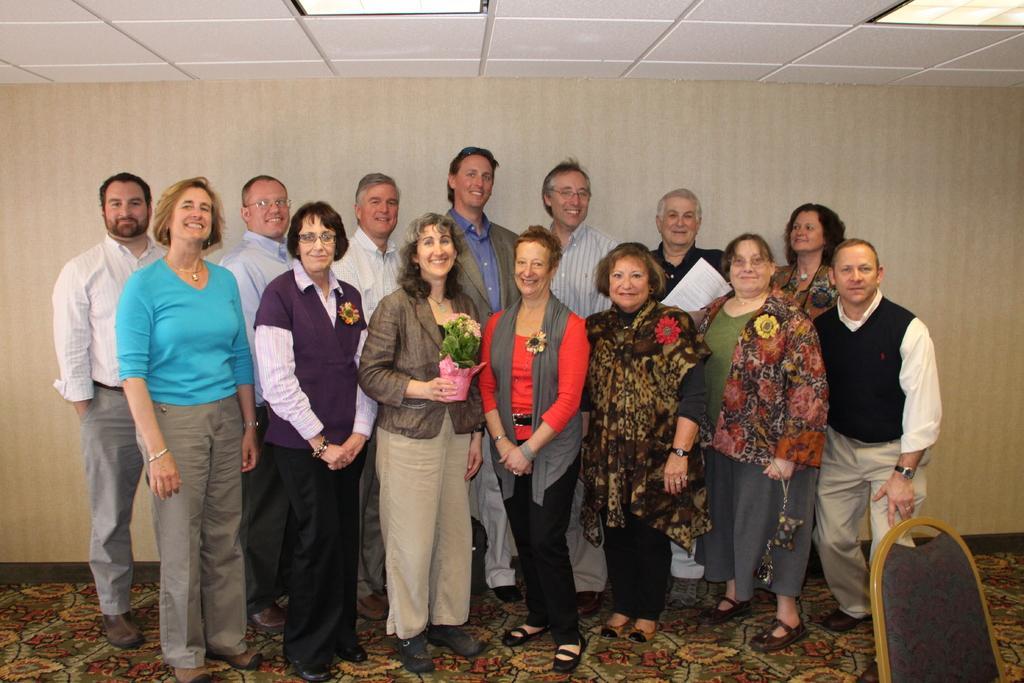Please provide a concise description of this image. In this image we can see a group of people standing on the floor. One woman is holding a flower pot in her hand. One person is wearing spectacles. In the foreground we can see a chair. In the background, we can see a wall and two lights in the ceiling. 